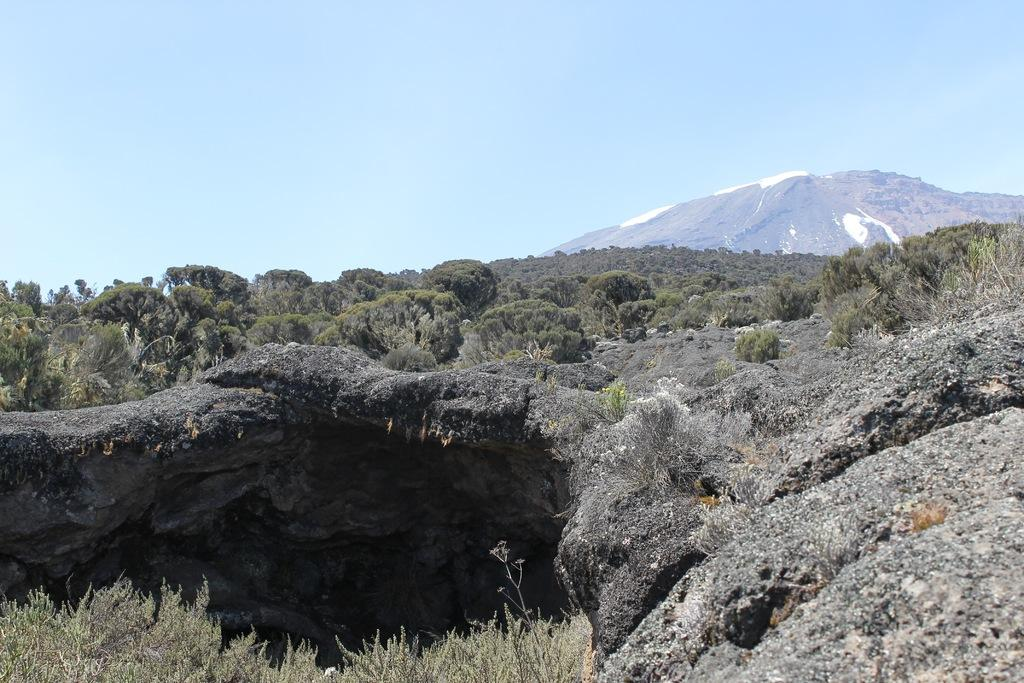What type of vegetation can be seen in the image? There are trees in the image. What geological feature is present in the image? There is a rock in the image. What type of landscape can be seen in the image? There are mountains in the image. What is visible in the background of the image? The sky is visible in the background of the image. What type of silk is being used to answer questions about the image? There is no silk present in the image, nor is it being used to answer questions about the image. 